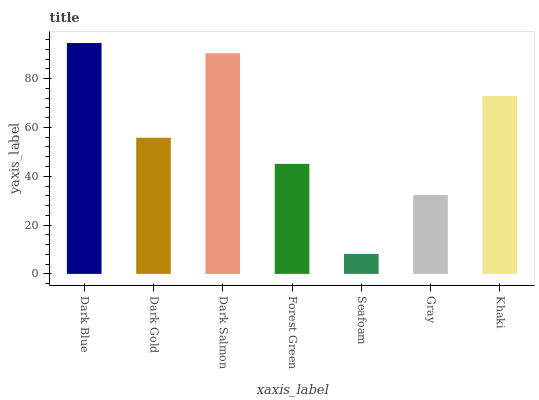Is Seafoam the minimum?
Answer yes or no. Yes. Is Dark Blue the maximum?
Answer yes or no. Yes. Is Dark Gold the minimum?
Answer yes or no. No. Is Dark Gold the maximum?
Answer yes or no. No. Is Dark Blue greater than Dark Gold?
Answer yes or no. Yes. Is Dark Gold less than Dark Blue?
Answer yes or no. Yes. Is Dark Gold greater than Dark Blue?
Answer yes or no. No. Is Dark Blue less than Dark Gold?
Answer yes or no. No. Is Dark Gold the high median?
Answer yes or no. Yes. Is Dark Gold the low median?
Answer yes or no. Yes. Is Gray the high median?
Answer yes or no. No. Is Gray the low median?
Answer yes or no. No. 